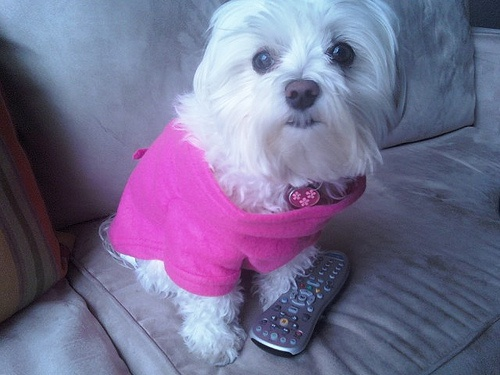Describe the objects in this image and their specific colors. I can see couch in lightblue, gray, and black tones, dog in lightblue, lavender, magenta, darkgray, and gray tones, and remote in lightblue, black, purple, and gray tones in this image. 